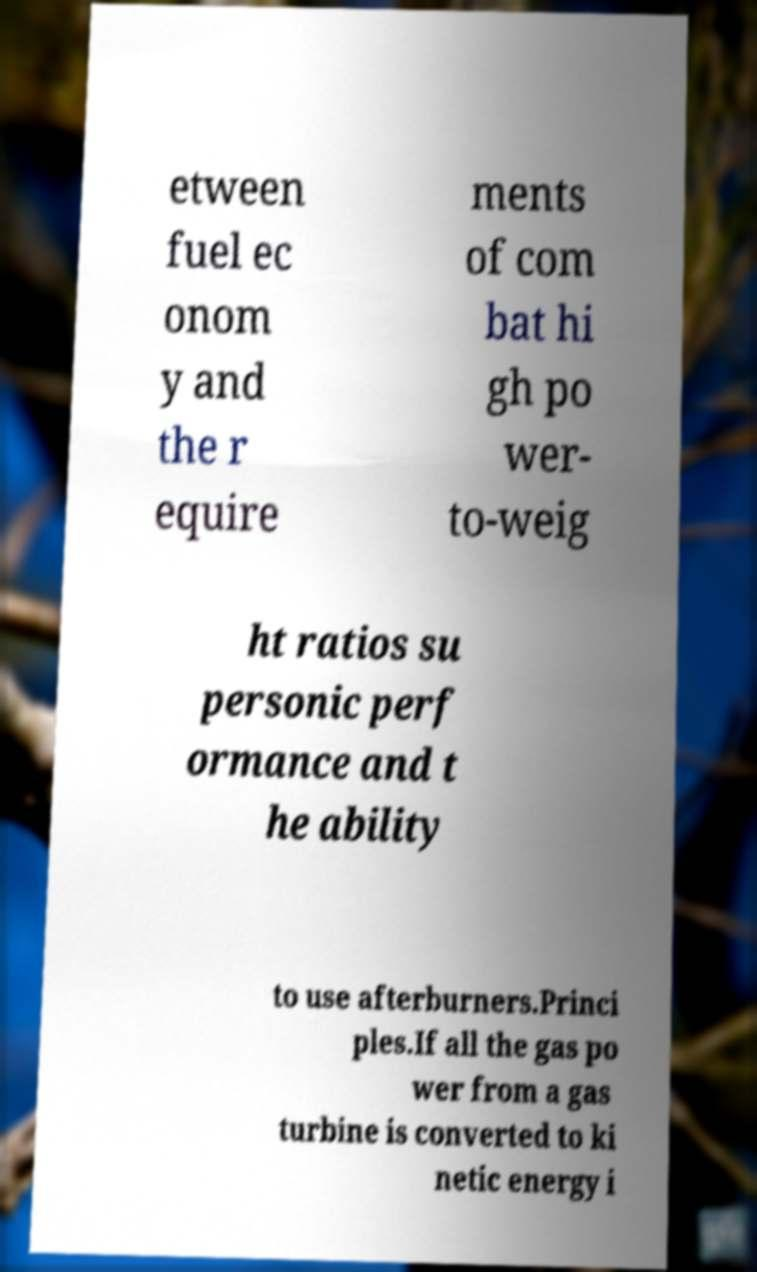Please identify and transcribe the text found in this image. etween fuel ec onom y and the r equire ments of com bat hi gh po wer- to-weig ht ratios su personic perf ormance and t he ability to use afterburners.Princi ples.If all the gas po wer from a gas turbine is converted to ki netic energy i 